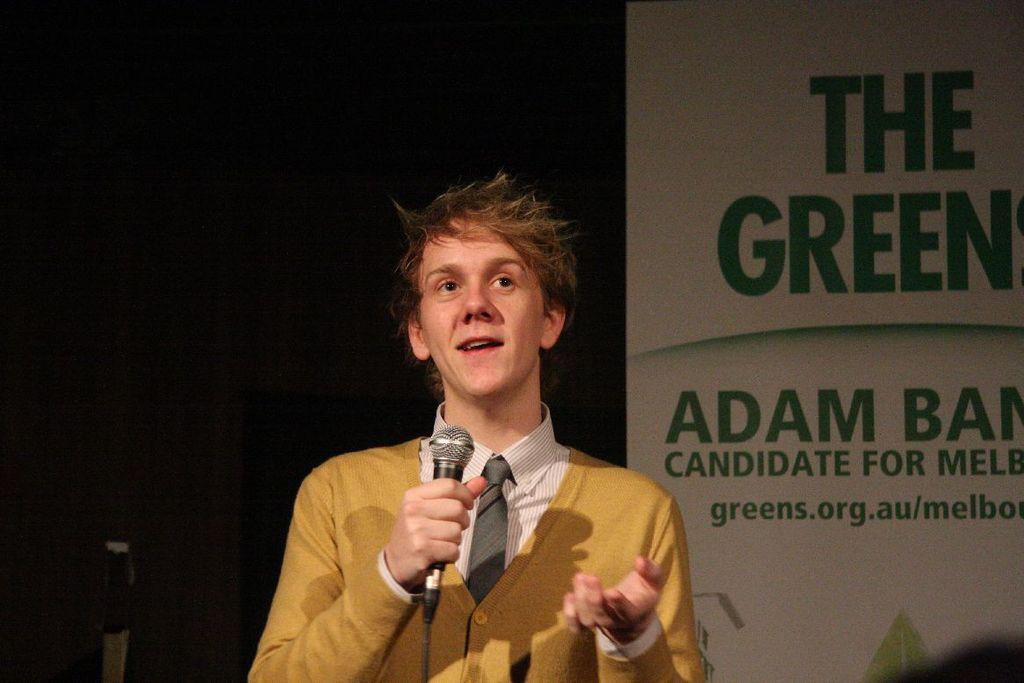Could you give a brief overview of what you see in this image? In the given image i can see a person holding a mike and behind him i can see a board with some text. 